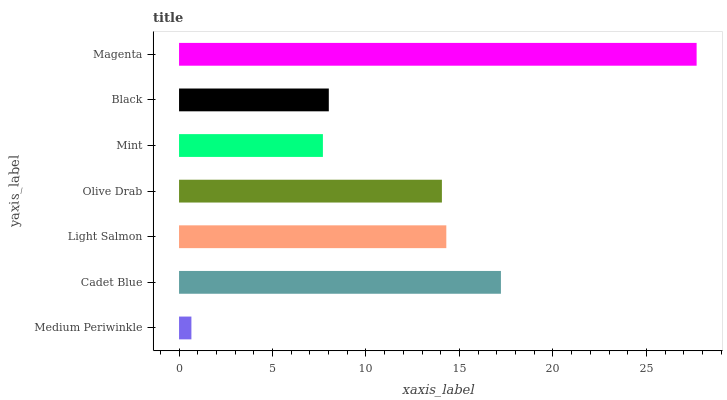Is Medium Periwinkle the minimum?
Answer yes or no. Yes. Is Magenta the maximum?
Answer yes or no. Yes. Is Cadet Blue the minimum?
Answer yes or no. No. Is Cadet Blue the maximum?
Answer yes or no. No. Is Cadet Blue greater than Medium Periwinkle?
Answer yes or no. Yes. Is Medium Periwinkle less than Cadet Blue?
Answer yes or no. Yes. Is Medium Periwinkle greater than Cadet Blue?
Answer yes or no. No. Is Cadet Blue less than Medium Periwinkle?
Answer yes or no. No. Is Olive Drab the high median?
Answer yes or no. Yes. Is Olive Drab the low median?
Answer yes or no. Yes. Is Magenta the high median?
Answer yes or no. No. Is Medium Periwinkle the low median?
Answer yes or no. No. 